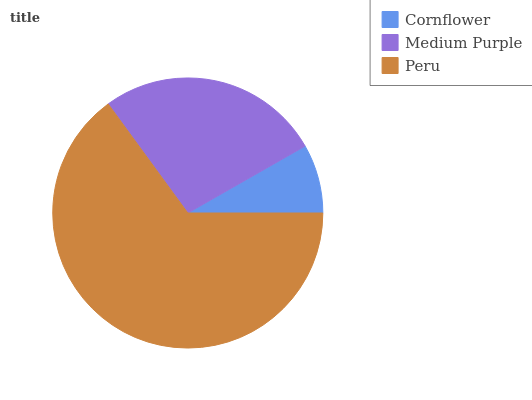Is Cornflower the minimum?
Answer yes or no. Yes. Is Peru the maximum?
Answer yes or no. Yes. Is Medium Purple the minimum?
Answer yes or no. No. Is Medium Purple the maximum?
Answer yes or no. No. Is Medium Purple greater than Cornflower?
Answer yes or no. Yes. Is Cornflower less than Medium Purple?
Answer yes or no. Yes. Is Cornflower greater than Medium Purple?
Answer yes or no. No. Is Medium Purple less than Cornflower?
Answer yes or no. No. Is Medium Purple the high median?
Answer yes or no. Yes. Is Medium Purple the low median?
Answer yes or no. Yes. Is Cornflower the high median?
Answer yes or no. No. Is Cornflower the low median?
Answer yes or no. No. 